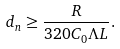Convert formula to latex. <formula><loc_0><loc_0><loc_500><loc_500>d _ { n } \geq \frac { R } { 3 2 0 C _ { 0 } { \Lambda } L } .</formula> 